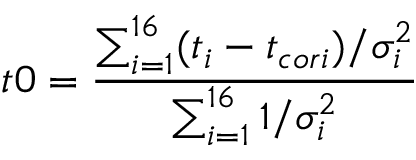<formula> <loc_0><loc_0><loc_500><loc_500>t 0 = \frac { \sum _ { i = 1 } ^ { 1 6 } ( t _ { i } - t _ { c o r i } ) / \sigma _ { i } ^ { 2 } } { \sum _ { i = 1 } ^ { 1 6 } 1 / \sigma _ { i } ^ { 2 } }</formula> 